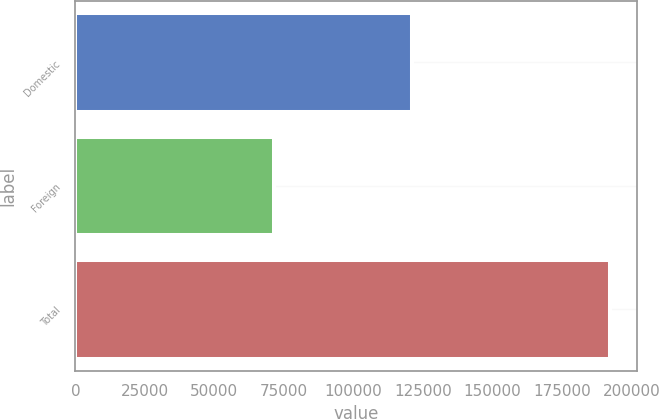<chart> <loc_0><loc_0><loc_500><loc_500><bar_chart><fcel>Domestic<fcel>Foreign<fcel>Total<nl><fcel>120962<fcel>71265<fcel>192227<nl></chart> 